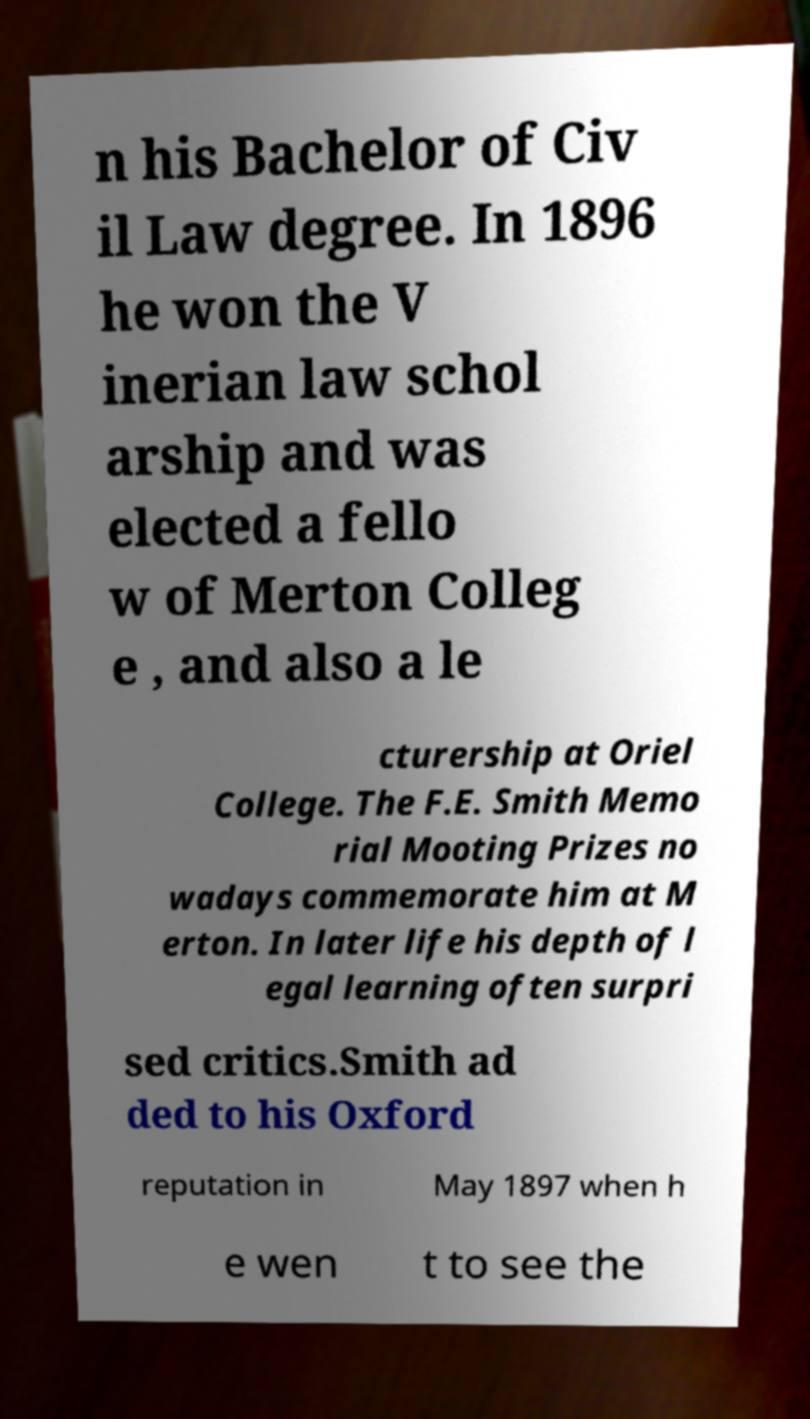I need the written content from this picture converted into text. Can you do that? n his Bachelor of Civ il Law degree. In 1896 he won the V inerian law schol arship and was elected a fello w of Merton Colleg e , and also a le cturership at Oriel College. The F.E. Smith Memo rial Mooting Prizes no wadays commemorate him at M erton. In later life his depth of l egal learning often surpri sed critics.Smith ad ded to his Oxford reputation in May 1897 when h e wen t to see the 